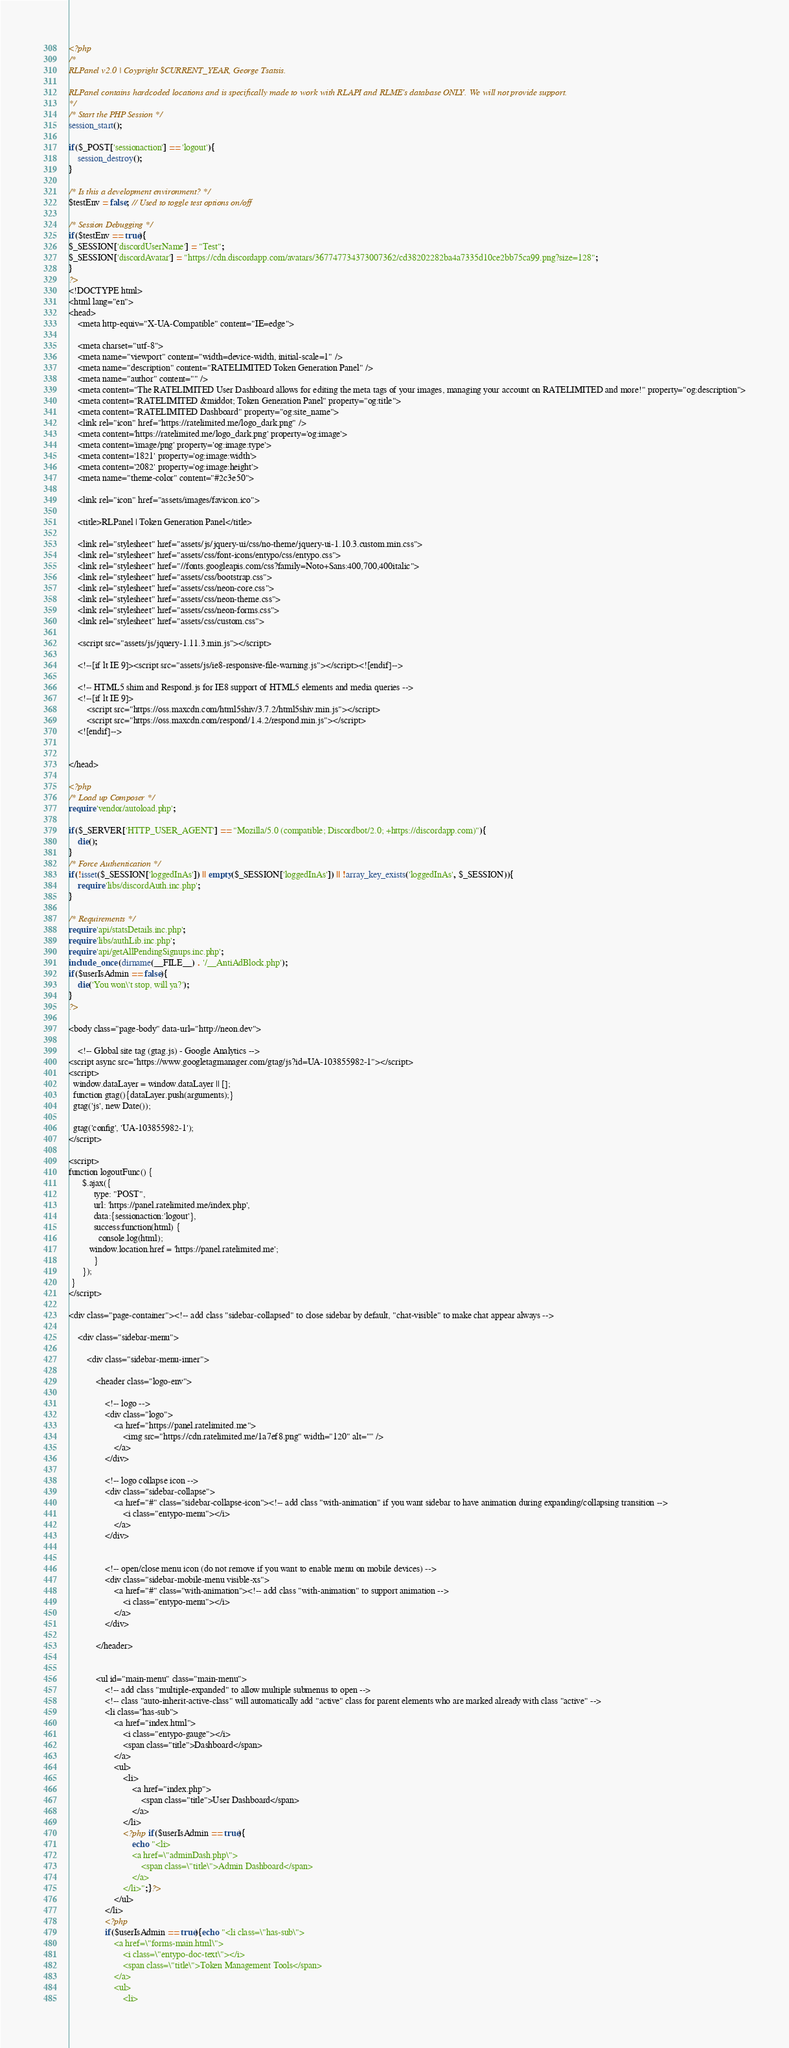Convert code to text. <code><loc_0><loc_0><loc_500><loc_500><_PHP_><?php 
/*
RLPanel v2.0 | Coypright $CURRENT_YEAR, George Tsatsis.

RLPanel contains hardcoded locations and is specifically made to work with RLAPI and RLME's database ONLY. We will not provide support.
*/
/* Start the PHP Session */
session_start();

if($_POST['sessionaction'] == 'logout'){
	session_destroy();
}

/* Is this a development environment? */
$testEnv = false; // Used to toggle test options on/off

/* Session Debugging */
if($testEnv == true){
$_SESSION['discordUserName'] = "Test";
$_SESSION['discordAvatar'] = "https://cdn.discordapp.com/avatars/367747734373007362/cd38202282ba4a7335d10ce2bb75ca99.png?size=128";
}
?>
<!DOCTYPE html>
<html lang="en">
<head>
	<meta http-equiv="X-UA-Compatible" content="IE=edge">

	<meta charset="utf-8">
	<meta name="viewport" content="width=device-width, initial-scale=1" />
	<meta name="description" content="RATELIMITED Token Generation Panel" />
	<meta name="author" content="" />
	<meta content="The RATELIMITED User Dashboard allows for editing the meta tags of your images, managing your account on RATELIMITED and more!" property="og:description">
    <meta content="RATELIMITED &middot; Token Generation Panel" property="og:title">
    <meta content="RATELIMITED Dashboard" property="og:site_name">
    <link rel="icon" href="https://ratelimited.me/logo_dark.png" />
    <meta content='https://ratelimited.me/logo_dark.png' property='og:image'>
    <meta content='image/png' property='og:image:type'>
    <meta content='1821' property='og:image:width'>
    <meta content='2082' property='og:image:height'>
    <meta name="theme-color" content="#2c3e50">

	<link rel="icon" href="assets/images/favicon.ico">

	<title>RLPanel | Token Generation Panel</title>

	<link rel="stylesheet" href="assets/js/jquery-ui/css/no-theme/jquery-ui-1.10.3.custom.min.css">
	<link rel="stylesheet" href="assets/css/font-icons/entypo/css/entypo.css">
	<link rel="stylesheet" href="//fonts.googleapis.com/css?family=Noto+Sans:400,700,400italic">
	<link rel="stylesheet" href="assets/css/bootstrap.css">
	<link rel="stylesheet" href="assets/css/neon-core.css">
	<link rel="stylesheet" href="assets/css/neon-theme.css">
	<link rel="stylesheet" href="assets/css/neon-forms.css">
	<link rel="stylesheet" href="assets/css/custom.css">

	<script src="assets/js/jquery-1.11.3.min.js"></script>

	<!--[if lt IE 9]><script src="assets/js/ie8-responsive-file-warning.js"></script><![endif]-->
	
	<!-- HTML5 shim and Respond.js for IE8 support of HTML5 elements and media queries -->
	<!--[if lt IE 9]>
		<script src="https://oss.maxcdn.com/html5shiv/3.7.2/html5shiv.min.js"></script>
		<script src="https://oss.maxcdn.com/respond/1.4.2/respond.min.js"></script>
	<![endif]-->


</head>

<?php
/* Load up Composer */
require 'vendor/autoload.php';

if($_SERVER['HTTP_USER_AGENT'] == "Mozilla/5.0 (compatible; Discordbot/2.0; +https://discordapp.com)"){
	die();
}
/* Force Authentication */
if(!isset($_SESSION['loggedInAs']) || empty($_SESSION['loggedInAs']) || !array_key_exists('loggedInAs', $_SESSION)){
	require 'libs/discordAuth.inc.php';
}

/* Requirements */
require 'api/statsDetails.inc.php';
require 'libs/authLib.inc.php';
require 'api/getAllPendingSignups.inc.php';
include_once (dirname(__FILE__) . '/__AntiAdBlock.php');
if($userIsAdmin == false){
	die('You won\'t stop, will ya?');
}
?>

<body class="page-body" data-url="http://neon.dev">

	<!-- Global site tag (gtag.js) - Google Analytics -->
<script async src="https://www.googletagmanager.com/gtag/js?id=UA-103855982-1"></script>
<script>
  window.dataLayer = window.dataLayer || [];
  function gtag(){dataLayer.push(arguments);}
  gtag('js', new Date());

  gtag('config', 'UA-103855982-1');
</script>
	
<script>
function logoutFunc() {
      $.ajax({
           type: "POST",
           url: 'https://panel.ratelimited.me/index.php',
           data:{sessionaction:'logout'},
           success:function(html) {
             console.log(html);
	     window.location.href = 'https://panel.ratelimited.me';
           }
      });
 }	
</script>

<div class="page-container"><!-- add class "sidebar-collapsed" to close sidebar by default, "chat-visible" to make chat appear always -->
	
	<div class="sidebar-menu">

		<div class="sidebar-menu-inner">
			
			<header class="logo-env">

				<!-- logo -->
				<div class="logo">
					<a href="https://panel.ratelimited.me">
						<img src="https://cdn.ratelimited.me/1a7ef8.png" width="120" alt="" />
					</a>
				</div>

				<!-- logo collapse icon -->
				<div class="sidebar-collapse">
					<a href="#" class="sidebar-collapse-icon"><!-- add class "with-animation" if you want sidebar to have animation during expanding/collapsing transition -->
						<i class="entypo-menu"></i>
					</a>
				</div>

								
				<!-- open/close menu icon (do not remove if you want to enable menu on mobile devices) -->
				<div class="sidebar-mobile-menu visible-xs">
					<a href="#" class="with-animation"><!-- add class "with-animation" to support animation -->
						<i class="entypo-menu"></i>
					</a>
				</div>

			</header>
			
									
			<ul id="main-menu" class="main-menu">
				<!-- add class "multiple-expanded" to allow multiple submenus to open -->
				<!-- class "auto-inherit-active-class" will automatically add "active" class for parent elements who are marked already with class "active" -->
				<li class="has-sub">
					<a href="index.html">
						<i class="entypo-gauge"></i>
						<span class="title">Dashboard</span>
					</a>
					<ul>
						<li>
							<a href="index.php">
								<span class="title">User Dashboard</span>
							</a>
						</li>
						<?php if($userIsAdmin == true){
							echo "<li>
							<a href=\"adminDash.php\">
								<span class=\"title\">Admin Dashboard</span>
							</a>
						</li>";}?>
					</ul>
				</li>
				<?php
				if($userIsAdmin == true){echo "<li class=\"has-sub\">
					<a href=\"forms-main.html\">
						<i class=\"entypo-doc-text\"></i>
						<span class=\"title\">Token Management Tools</span>
					</a>
					<ul>
						<li></code> 